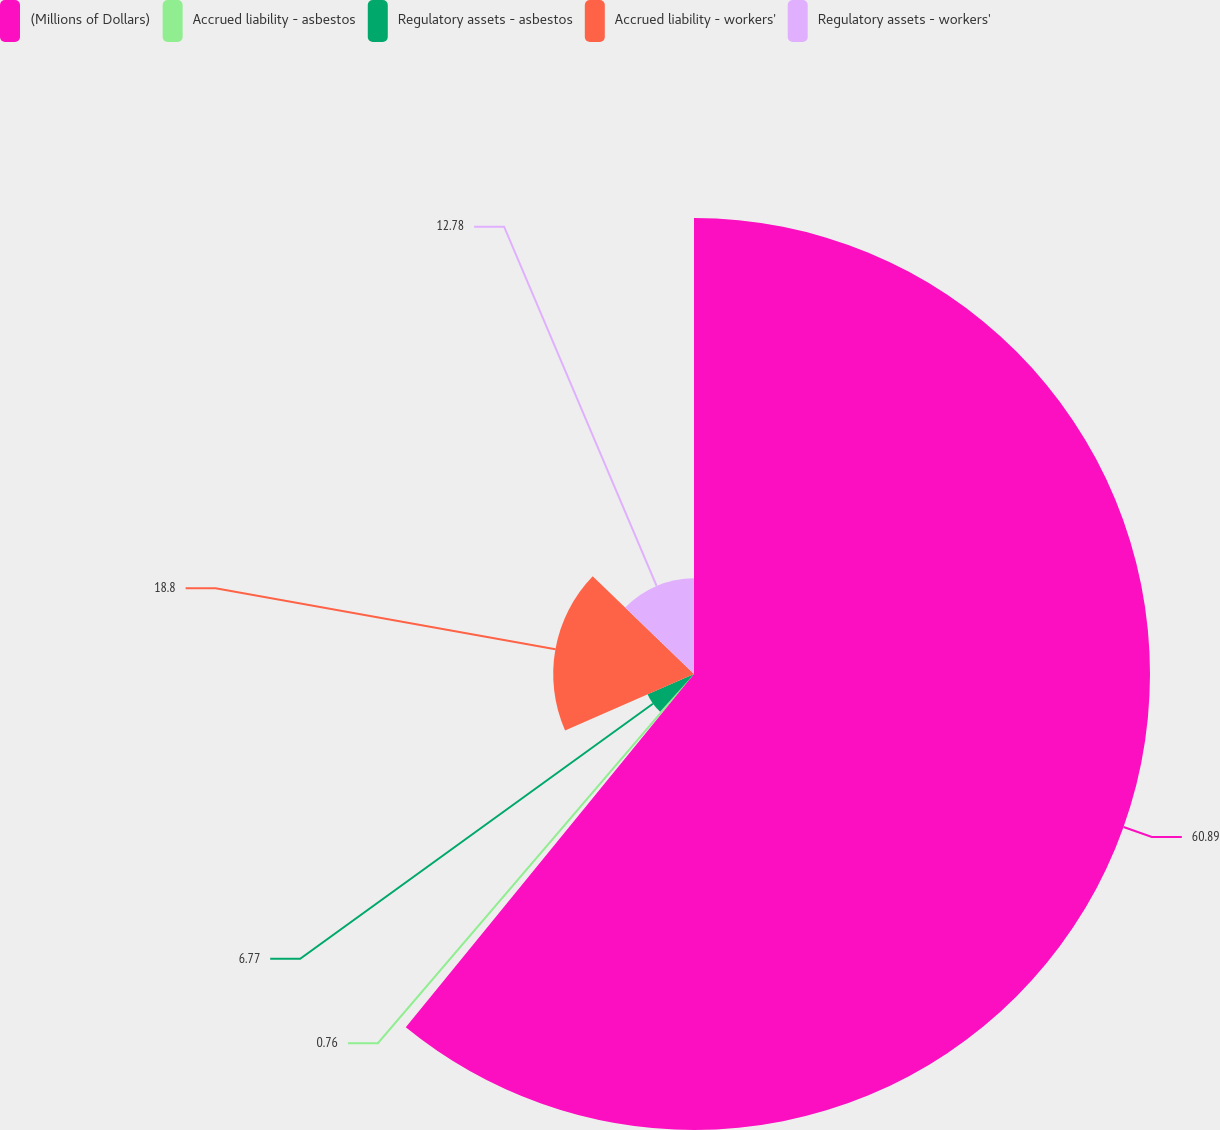<chart> <loc_0><loc_0><loc_500><loc_500><pie_chart><fcel>(Millions of Dollars)<fcel>Accrued liability - asbestos<fcel>Regulatory assets - asbestos<fcel>Accrued liability - workers'<fcel>Regulatory assets - workers'<nl><fcel>60.89%<fcel>0.76%<fcel>6.77%<fcel>18.8%<fcel>12.78%<nl></chart> 